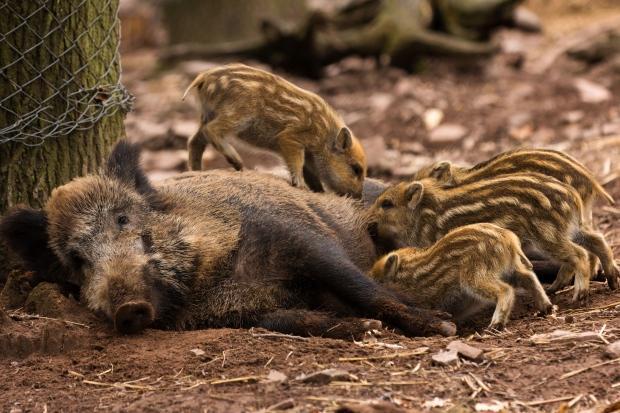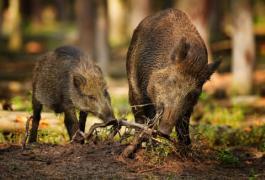The first image is the image on the left, the second image is the image on the right. Evaluate the accuracy of this statement regarding the images: "There are exactly three pigs.". Is it true? Answer yes or no. No. The first image is the image on the left, the second image is the image on the right. For the images displayed, is the sentence "There are three hogs in the pair of images." factually correct? Answer yes or no. No. 